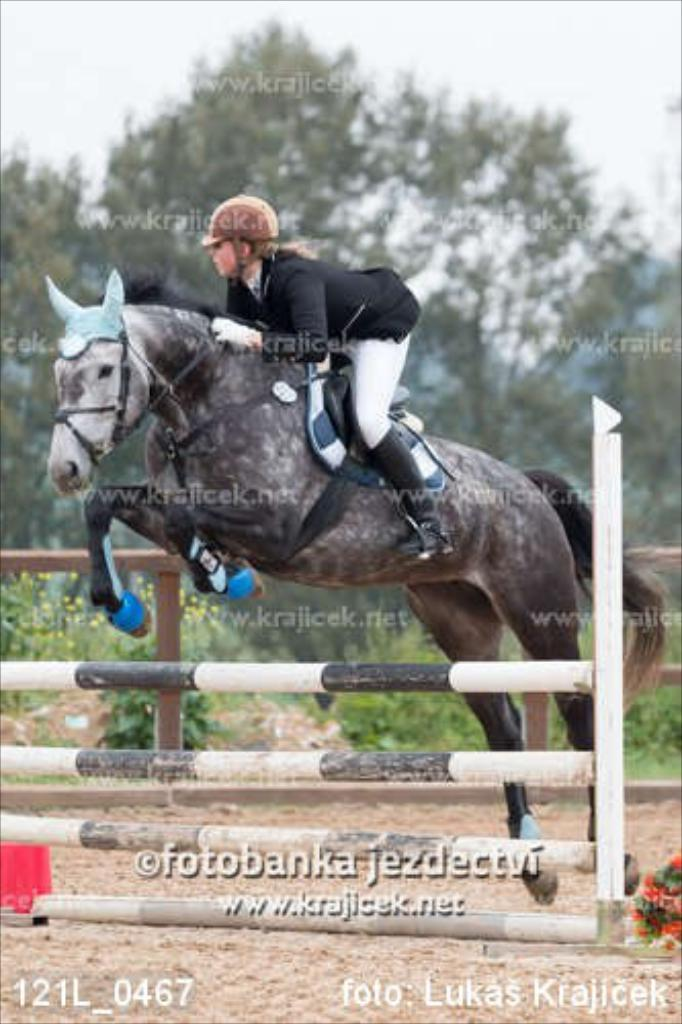What is the main subject of the image? There is a person in the image. What is the person doing in the image? The person is riding a horse. What is happening as the person rides the horse? The person is passing through a barricade. What can be seen in the background of the image? There are trees and plants visible in the background. What safety equipment is the person wearing? The person is wearing a helmet. What type of stove can be seen in the image? There is no stove present in the image. How many roses are visible in the image? There are no roses visible in the image. 